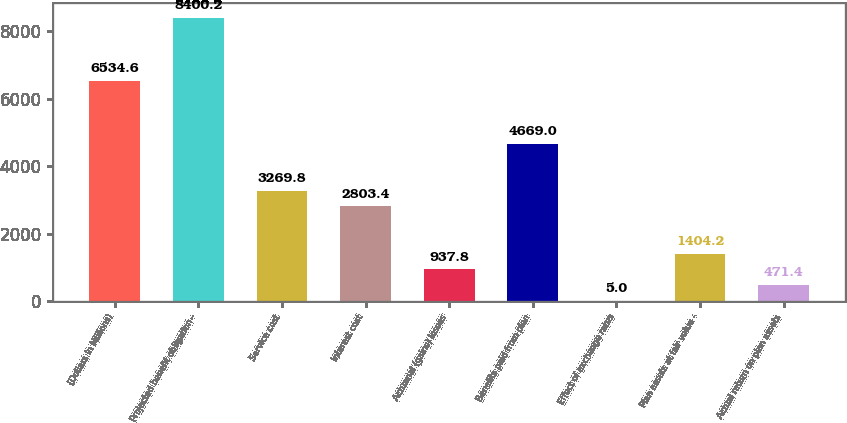Convert chart to OTSL. <chart><loc_0><loc_0><loc_500><loc_500><bar_chart><fcel>(Dollars in Millions)<fcel>Projected benefit obligation -<fcel>Service cost<fcel>Interest cost<fcel>Actuarial (gains) losses<fcel>Benefits paid from plan<fcel>Effect of exchange rates<fcel>Plan assets at fair value -<fcel>Actual return on plan assets<nl><fcel>6534.6<fcel>8400.2<fcel>3269.8<fcel>2803.4<fcel>937.8<fcel>4669<fcel>5<fcel>1404.2<fcel>471.4<nl></chart> 